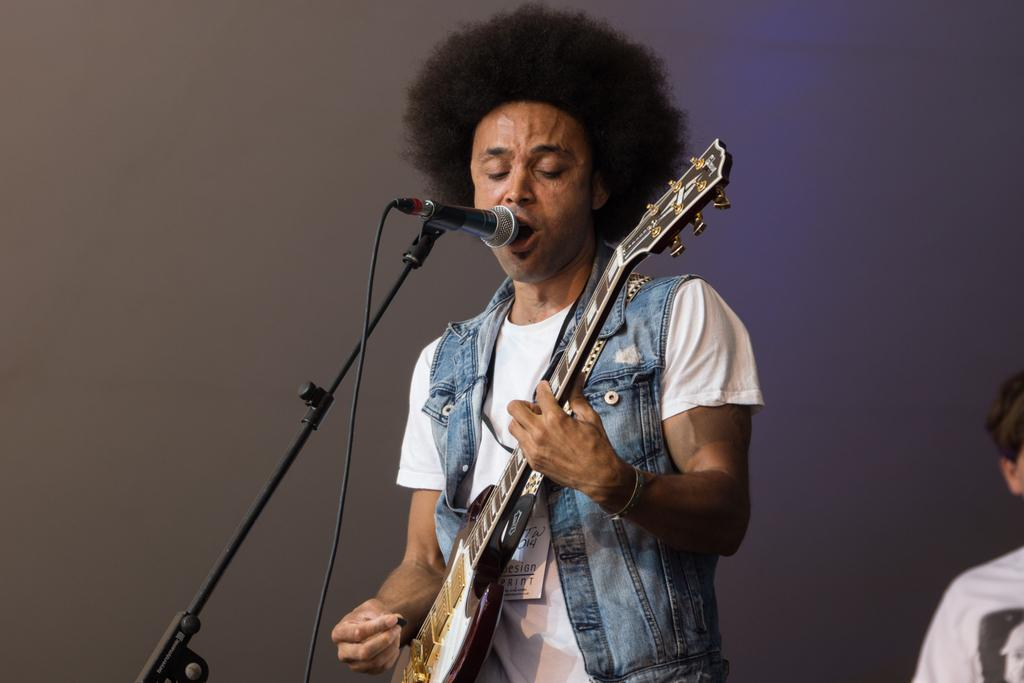What is the man in the image doing? The man is playing a guitar and singing. What is the man wearing in the image? The man is wearing a white t-shirt and a blue jacket. What objects are present in the image related to the man's singing? There is a microphone and a microphone stand in the image. What is the color of the background in the image? The background of the image is gray. Can you tell me how many times the man in the image has experienced an earthquake? There is no information about the man's experience with earthquakes in the image, so it cannot be determined. How does the man in the image plan to fly to his next performance? There is no information about the man's transportation or future performances in the image, so it cannot be determined. 